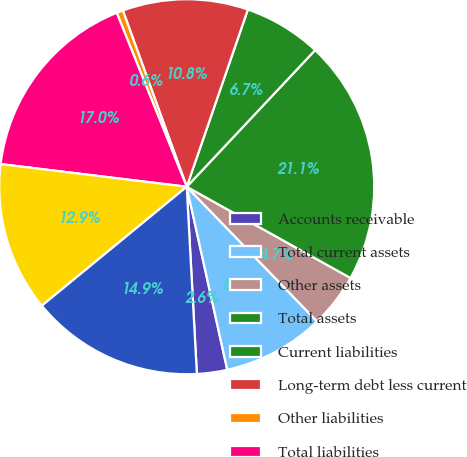Convert chart to OTSL. <chart><loc_0><loc_0><loc_500><loc_500><pie_chart><fcel>Accounts receivable<fcel>Total current assets<fcel>Other assets<fcel>Total assets<fcel>Current liabilities<fcel>Long-term debt less current<fcel>Other liabilities<fcel>Total liabilities<fcel>Stockholders' equity<fcel>Total equity<nl><fcel>2.61%<fcel>8.77%<fcel>4.67%<fcel>21.08%<fcel>6.72%<fcel>10.82%<fcel>0.56%<fcel>16.98%<fcel>12.87%<fcel>14.92%<nl></chart> 